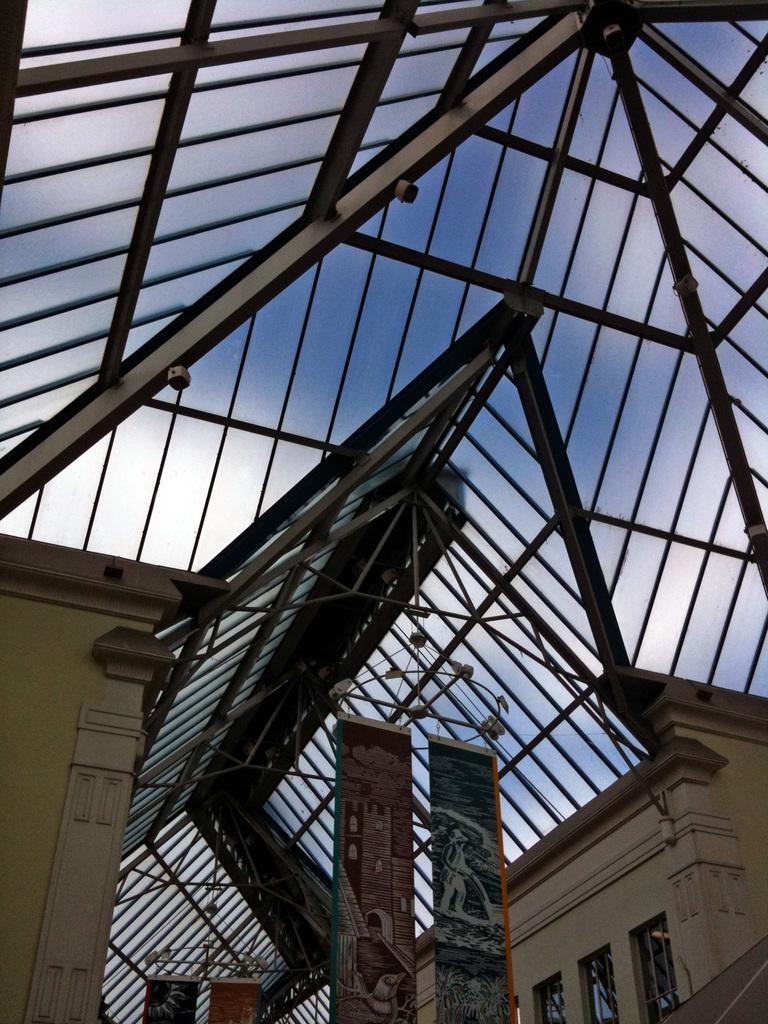What can be seen hanging from the top of the ceiling in the center of the image? There are banners hanging from the top of the ceiling in the center of the image. What type of roof is visible in the background of the image? There is a glass roof in the background of the image. What supports the glass roof? The glass roof has metal bars supporting it. What type of vegetable is being used as a support for the banners in the image? There are no vegetables present in the image, and the banners are not supported by any vegetable. How does the bun help to hold up the glass roof in the image? There are no buns present in the image, and they are not involved in supporting the glass roof. 